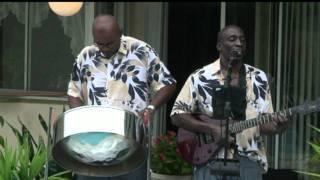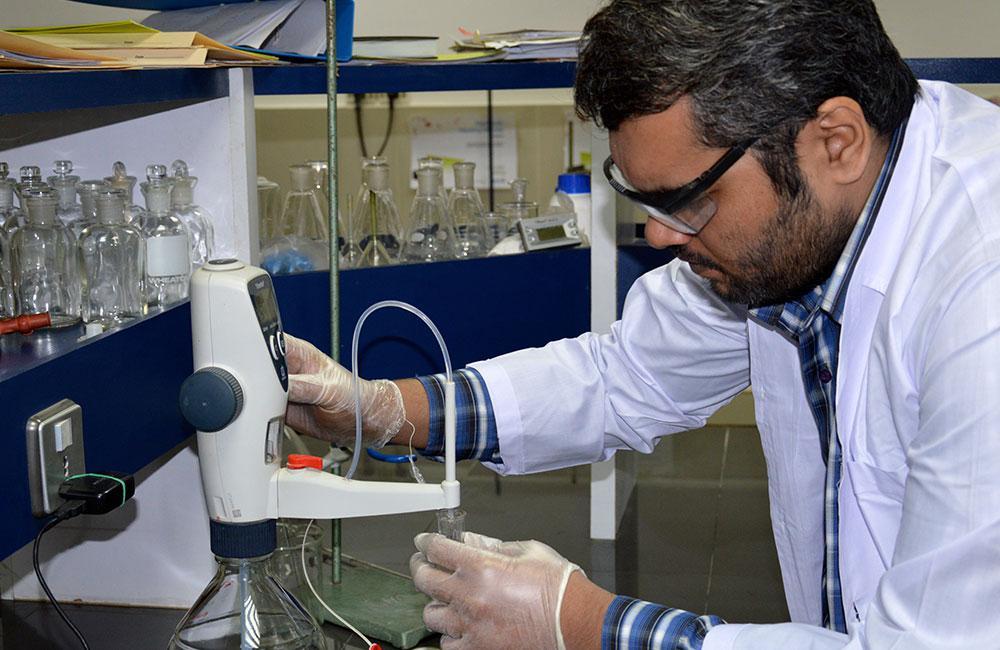The first image is the image on the left, the second image is the image on the right. For the images shown, is this caption "The left and right image contains seven drums." true? Answer yes or no. No. 